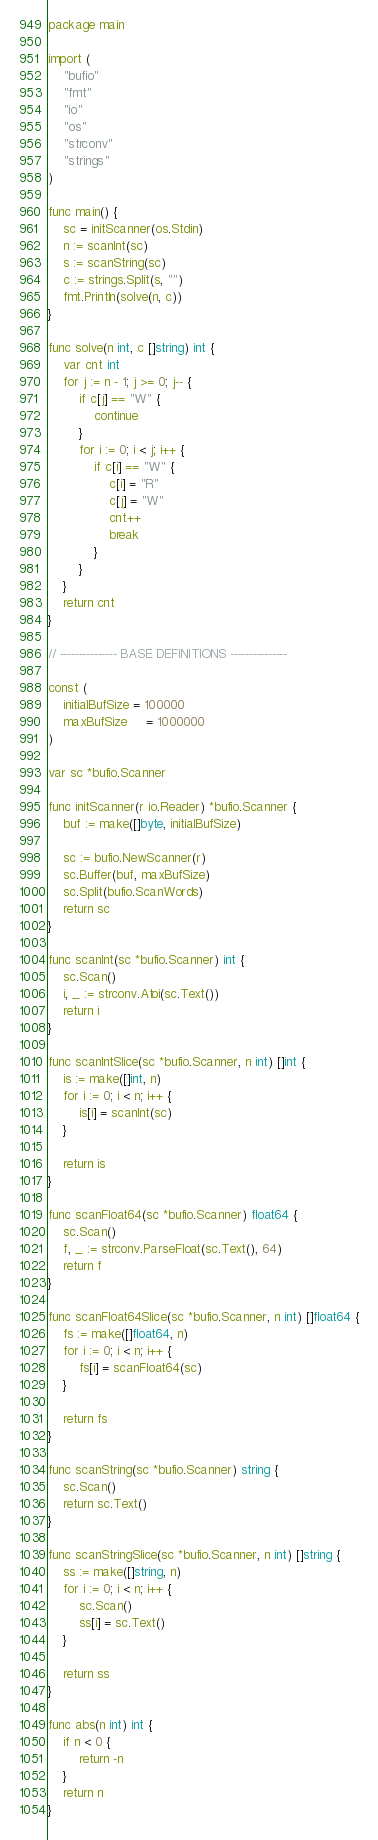Convert code to text. <code><loc_0><loc_0><loc_500><loc_500><_Go_>package main

import (
	"bufio"
	"fmt"
	"io"
	"os"
	"strconv"
	"strings"
)

func main() {
	sc = initScanner(os.Stdin)
	n := scanInt(sc)
	s := scanString(sc)
	c := strings.Split(s, "")
	fmt.Println(solve(n, c))
}

func solve(n int, c []string) int {
	var cnt int
	for j := n - 1; j >= 0; j-- {
		if c[j] == "W" {
			continue
		}
		for i := 0; i < j; i++ {
			if c[i] == "W" {
				c[i] = "R"
				c[j] = "W"
				cnt++
				break
			}
		}
	}
	return cnt
}

// --------------- BASE DEFINITIONS ---------------

const (
	initialBufSize = 100000
	maxBufSize     = 1000000
)

var sc *bufio.Scanner

func initScanner(r io.Reader) *bufio.Scanner {
	buf := make([]byte, initialBufSize)

	sc := bufio.NewScanner(r)
	sc.Buffer(buf, maxBufSize)
	sc.Split(bufio.ScanWords)
	return sc
}

func scanInt(sc *bufio.Scanner) int {
	sc.Scan()
	i, _ := strconv.Atoi(sc.Text())
	return i
}

func scanIntSlice(sc *bufio.Scanner, n int) []int {
	is := make([]int, n)
	for i := 0; i < n; i++ {
		is[i] = scanInt(sc)
	}

	return is
}

func scanFloat64(sc *bufio.Scanner) float64 {
	sc.Scan()
	f, _ := strconv.ParseFloat(sc.Text(), 64)
	return f
}

func scanFloat64Slice(sc *bufio.Scanner, n int) []float64 {
	fs := make([]float64, n)
	for i := 0; i < n; i++ {
		fs[i] = scanFloat64(sc)
	}

	return fs
}

func scanString(sc *bufio.Scanner) string {
	sc.Scan()
	return sc.Text()
}

func scanStringSlice(sc *bufio.Scanner, n int) []string {
	ss := make([]string, n)
	for i := 0; i < n; i++ {
		sc.Scan()
		ss[i] = sc.Text()
	}

	return ss
}

func abs(n int) int {
	if n < 0 {
		return -n
	}
	return n
}
</code> 